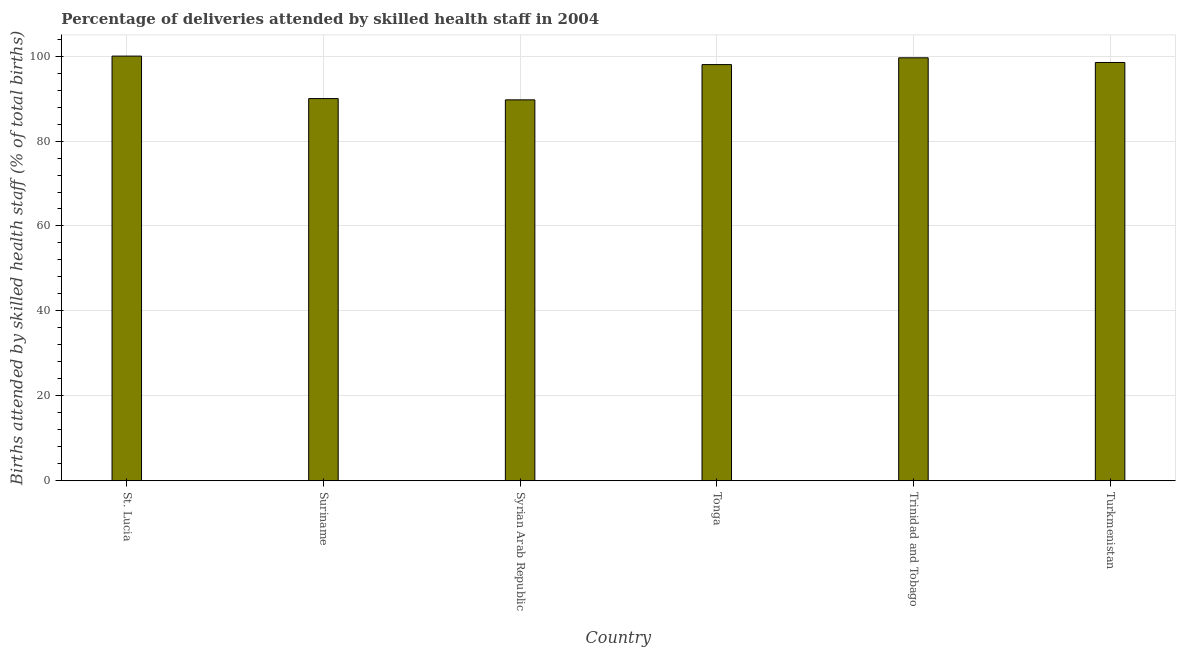Does the graph contain any zero values?
Keep it short and to the point. No. What is the title of the graph?
Ensure brevity in your answer.  Percentage of deliveries attended by skilled health staff in 2004. What is the label or title of the Y-axis?
Your answer should be compact. Births attended by skilled health staff (% of total births). What is the number of births attended by skilled health staff in Tonga?
Your answer should be compact. 98. Across all countries, what is the minimum number of births attended by skilled health staff?
Your answer should be compact. 89.7. In which country was the number of births attended by skilled health staff maximum?
Offer a terse response. St. Lucia. In which country was the number of births attended by skilled health staff minimum?
Ensure brevity in your answer.  Syrian Arab Republic. What is the sum of the number of births attended by skilled health staff?
Your answer should be very brief. 575.8. What is the average number of births attended by skilled health staff per country?
Provide a short and direct response. 95.97. What is the median number of births attended by skilled health staff?
Provide a short and direct response. 98.25. In how many countries, is the number of births attended by skilled health staff greater than 8 %?
Offer a terse response. 6. What is the ratio of the number of births attended by skilled health staff in St. Lucia to that in Tonga?
Ensure brevity in your answer.  1.02. Is the difference between the number of births attended by skilled health staff in Suriname and Tonga greater than the difference between any two countries?
Make the answer very short. No. What is the difference between the highest and the lowest number of births attended by skilled health staff?
Provide a succinct answer. 10.3. How many bars are there?
Give a very brief answer. 6. How many countries are there in the graph?
Offer a very short reply. 6. What is the Births attended by skilled health staff (% of total births) of Syrian Arab Republic?
Provide a short and direct response. 89.7. What is the Births attended by skilled health staff (% of total births) of Tonga?
Ensure brevity in your answer.  98. What is the Births attended by skilled health staff (% of total births) in Trinidad and Tobago?
Offer a terse response. 99.6. What is the Births attended by skilled health staff (% of total births) in Turkmenistan?
Give a very brief answer. 98.5. What is the difference between the Births attended by skilled health staff (% of total births) in St. Lucia and Suriname?
Offer a very short reply. 10. What is the difference between the Births attended by skilled health staff (% of total births) in St. Lucia and Trinidad and Tobago?
Your response must be concise. 0.4. What is the difference between the Births attended by skilled health staff (% of total births) in St. Lucia and Turkmenistan?
Your answer should be compact. 1.5. What is the difference between the Births attended by skilled health staff (% of total births) in Suriname and Syrian Arab Republic?
Your answer should be compact. 0.3. What is the difference between the Births attended by skilled health staff (% of total births) in Suriname and Tonga?
Offer a terse response. -8. What is the difference between the Births attended by skilled health staff (% of total births) in Suriname and Trinidad and Tobago?
Your answer should be compact. -9.6. What is the difference between the Births attended by skilled health staff (% of total births) in Syrian Arab Republic and Trinidad and Tobago?
Keep it short and to the point. -9.9. What is the difference between the Births attended by skilled health staff (% of total births) in Syrian Arab Republic and Turkmenistan?
Offer a very short reply. -8.8. What is the difference between the Births attended by skilled health staff (% of total births) in Tonga and Turkmenistan?
Keep it short and to the point. -0.5. What is the difference between the Births attended by skilled health staff (% of total births) in Trinidad and Tobago and Turkmenistan?
Keep it short and to the point. 1.1. What is the ratio of the Births attended by skilled health staff (% of total births) in St. Lucia to that in Suriname?
Keep it short and to the point. 1.11. What is the ratio of the Births attended by skilled health staff (% of total births) in St. Lucia to that in Syrian Arab Republic?
Give a very brief answer. 1.11. What is the ratio of the Births attended by skilled health staff (% of total births) in St. Lucia to that in Tonga?
Offer a very short reply. 1.02. What is the ratio of the Births attended by skilled health staff (% of total births) in St. Lucia to that in Trinidad and Tobago?
Ensure brevity in your answer.  1. What is the ratio of the Births attended by skilled health staff (% of total births) in St. Lucia to that in Turkmenistan?
Offer a terse response. 1.01. What is the ratio of the Births attended by skilled health staff (% of total births) in Suriname to that in Syrian Arab Republic?
Your answer should be compact. 1. What is the ratio of the Births attended by skilled health staff (% of total births) in Suriname to that in Tonga?
Your answer should be very brief. 0.92. What is the ratio of the Births attended by skilled health staff (% of total births) in Suriname to that in Trinidad and Tobago?
Keep it short and to the point. 0.9. What is the ratio of the Births attended by skilled health staff (% of total births) in Suriname to that in Turkmenistan?
Make the answer very short. 0.91. What is the ratio of the Births attended by skilled health staff (% of total births) in Syrian Arab Republic to that in Tonga?
Offer a terse response. 0.92. What is the ratio of the Births attended by skilled health staff (% of total births) in Syrian Arab Republic to that in Trinidad and Tobago?
Keep it short and to the point. 0.9. What is the ratio of the Births attended by skilled health staff (% of total births) in Syrian Arab Republic to that in Turkmenistan?
Give a very brief answer. 0.91. What is the ratio of the Births attended by skilled health staff (% of total births) in Tonga to that in Trinidad and Tobago?
Offer a very short reply. 0.98. What is the ratio of the Births attended by skilled health staff (% of total births) in Tonga to that in Turkmenistan?
Offer a terse response. 0.99. What is the ratio of the Births attended by skilled health staff (% of total births) in Trinidad and Tobago to that in Turkmenistan?
Provide a succinct answer. 1.01. 